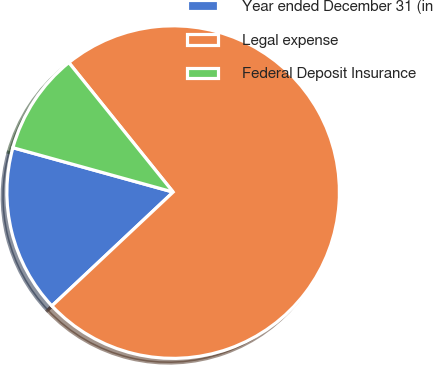<chart> <loc_0><loc_0><loc_500><loc_500><pie_chart><fcel>Year ended December 31 (in<fcel>Legal expense<fcel>Federal Deposit Insurance<nl><fcel>16.3%<fcel>73.8%<fcel>9.91%<nl></chart> 